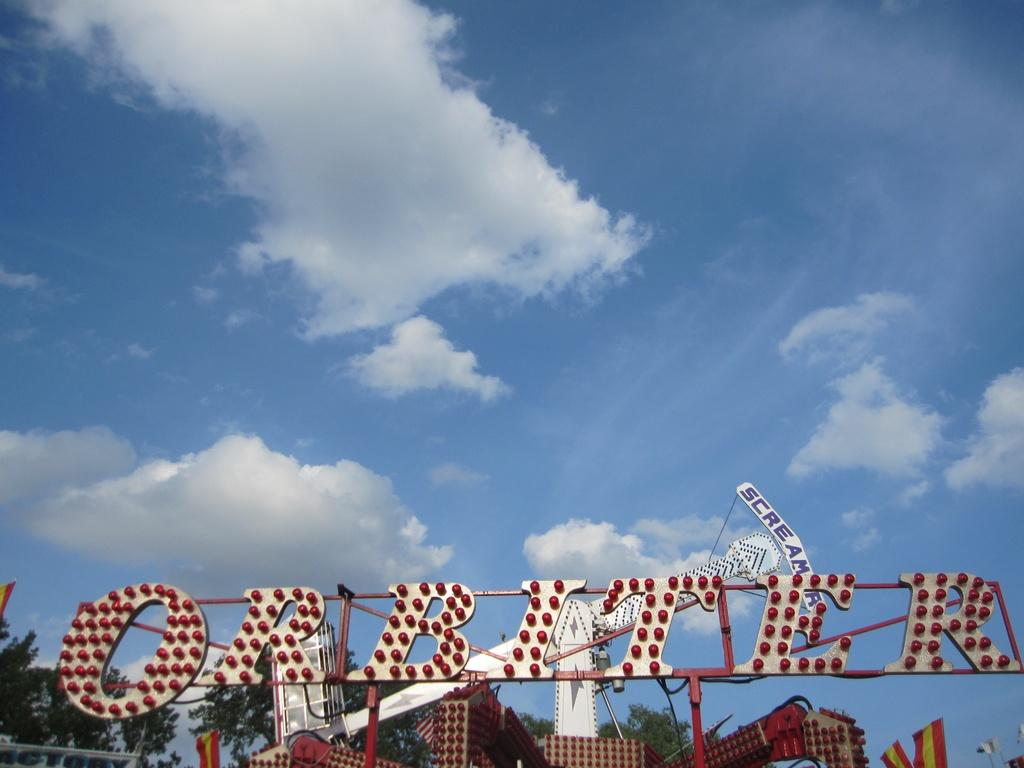What objects can be seen in the image that are related to lighting? There are bulbs and lights in the image. What other objects can be seen in the image? There are boards, flags, trees, and clouds visible in the sky. Can you describe the flags in the image? The flags are in the image, but their specific design or color is not mentioned in the provided facts. What is the condition of the sky in the image? The sky is visible in the image, and there are clouds present. How many minutes does it take for the flock of birds to fly across the image? There is no flock of birds present in the image, so it is not possible to determine how long it would take for them to fly across the image. 